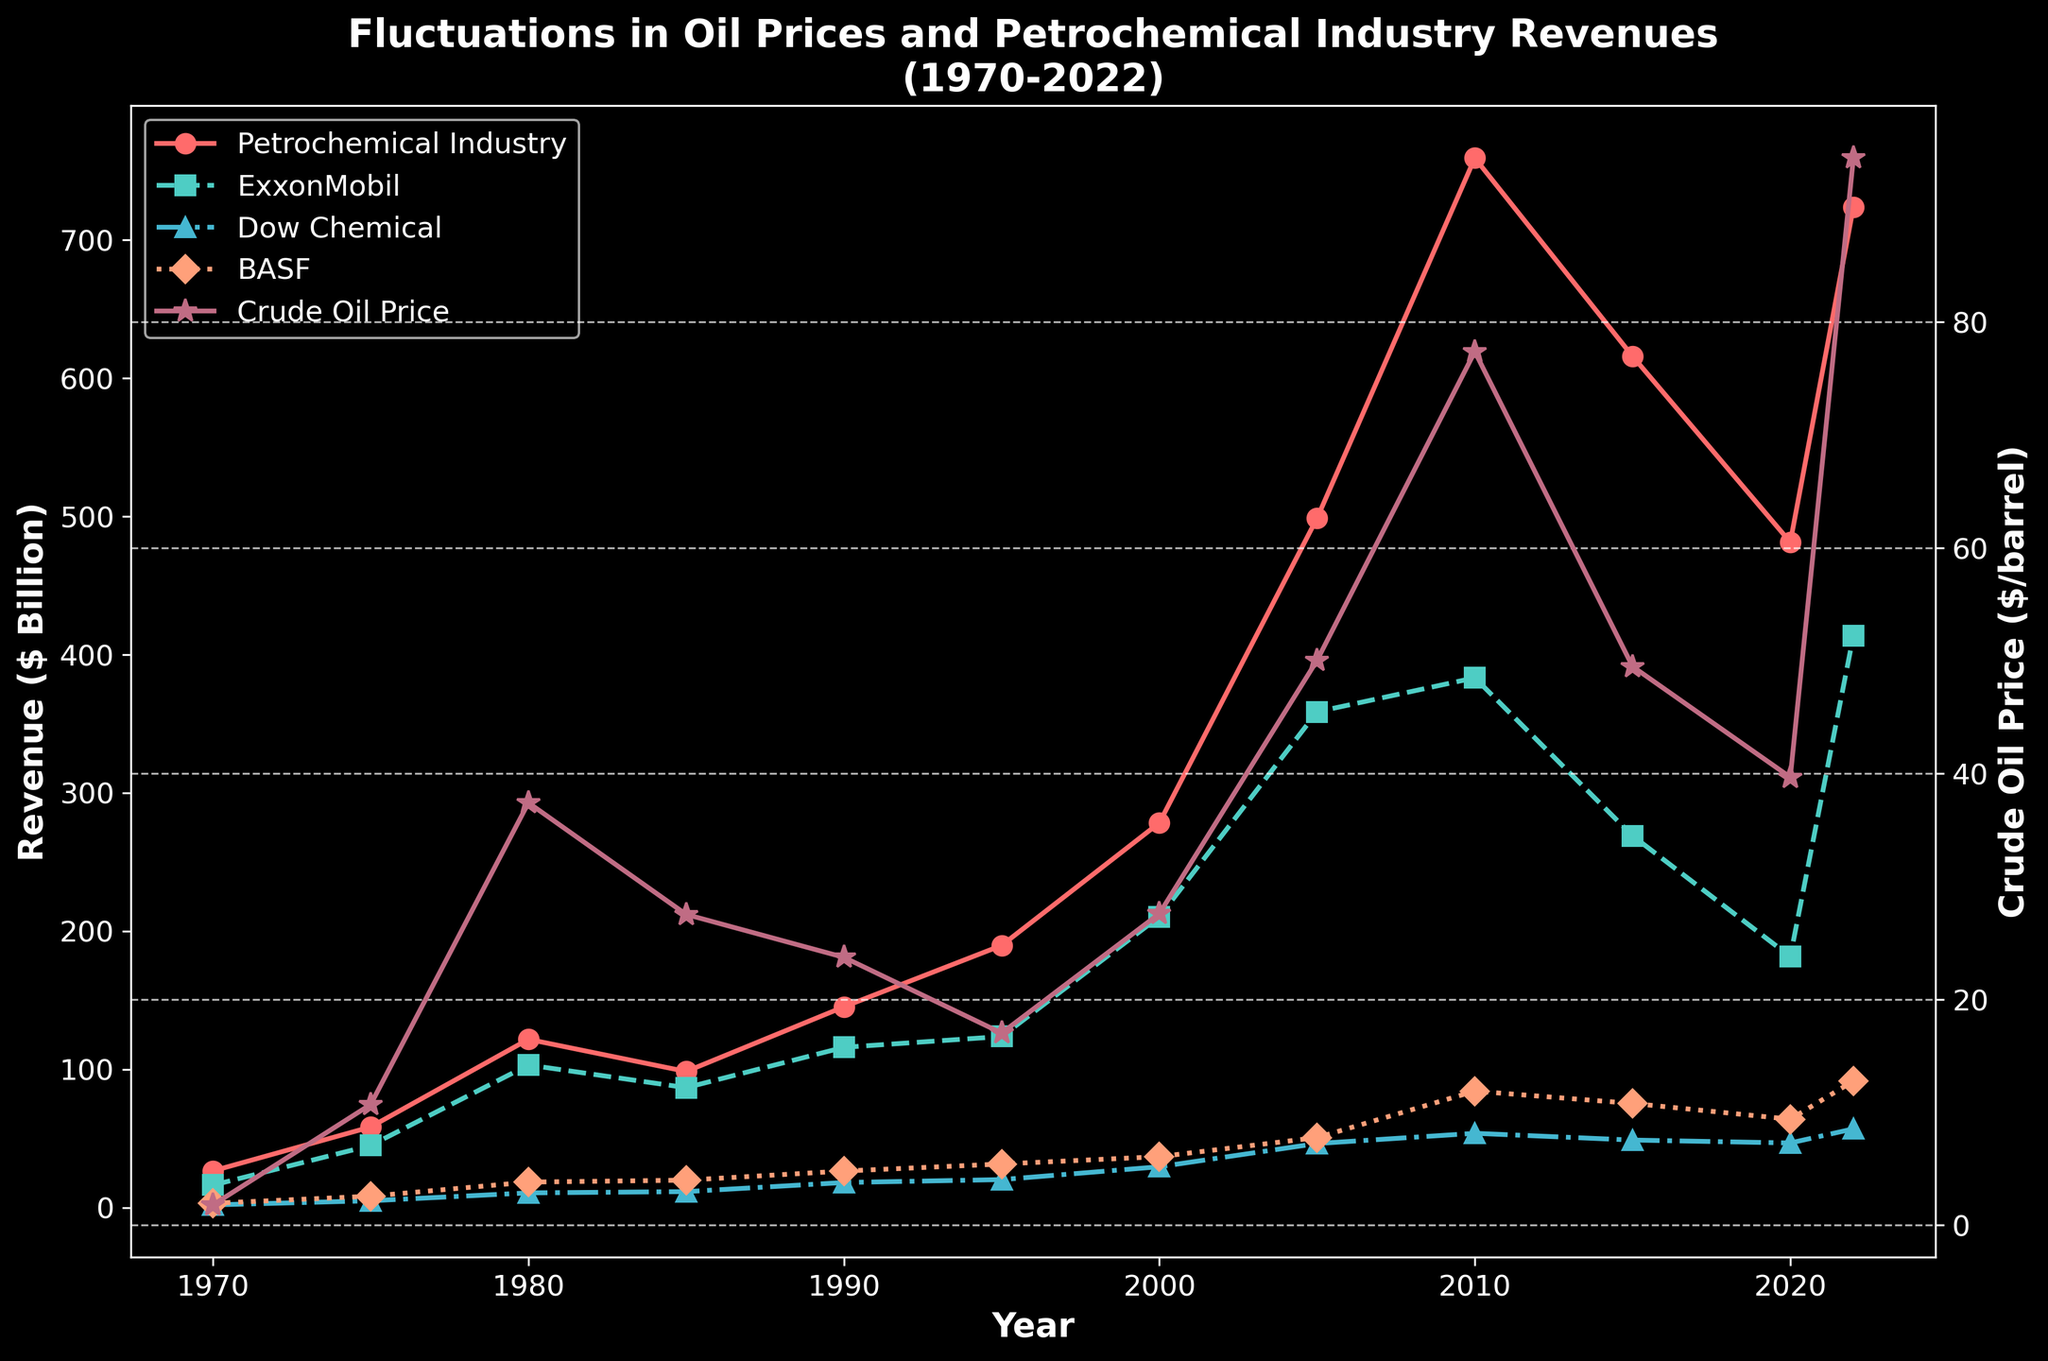What was the Petrochemical Industry Revenue in 1980? Find the point on the Petrochemical Industry Revenue line corresponding to the year 1980. The value at this point is 121.7.
Answer: 121.7 billion dollars Which company had the highest revenue in 2022? Compare the revenues of ExxonMobil, Dow Chemical, and BASF for the year 2022. ExxonMobil has 413.7, Dow Chemical has 56.9, and BASF has 91.5. ExxonMobil has the highest revenue.
Answer: ExxonMobil During which year was the Crude Oil Price the highest, and how much was it? Identify the highest point on the Crude Oil Price line, which occurs in 2022. The corresponding value is 94.53.
Answer: 2022 and 94.53 dollars per barrel Between which years did ExxonMobil’s Revenue experience the largest drop? Compare the changes in ExxonMobil’s Revenue between consecutive years. The largest drop occurs between 2010 (383.2) and 2015 (268.9), giving a decrease of 114.3 billion dollars.
Answer: 2010 and 2015 What is the average revenue of Dow Chemical between 2000 and 2020? Find the revenues of Dow Chemical in the years 2000, 2005, 2010, 2015, and 2020. Sum them up: 29.5 + 46.3 + 53.7 + 48.8 + 46.7 = 225. Find the average: 225 / 5 = 45.
Answer: 45 billion dollars Did BASF Revenue ever surpass the Petrochemical Industry Revenue? If yes, when? Compare the lines representing BASF Revenue and Petrochemical Industry Revenue. BASF's line is always below the Petrochemical Industry Revenue line, meaning BASF never surpassed the Petrochemical Industry Revenue.
Answer: No During which year did Crude Oil Price approximately double its value compared to the previous year? Search for a year-to-year increase where the Crude Oil Price approximately doubles. In 1975, the Crude Oil Price is 10.70, roughly 6 times the value in 1970 (1.80). While not an exact double, such a significant increase only occurs between these years.
Answer: 1975 Which year showed the highest revenue for the Petrochemical Industry, and what was the amount? Identify the highest point on the Petrochemical Industry Revenue line, which occurs in 2010. The value at this point is 759.2.
Answer: 2010 and 759.2 billion dollars How did Dow Chemical Revenue trend from 1995 to 2000 compared to Crude Oil Price? Compare the trend lines for Dow Chemical Revenue and Crude Oil Price from 1995 to 2000. Dow Chemical Revenue increased from 20.2 to 29.5 (an increasing trend), while Crude Oil Price also increased from 17.02 to 27.60 (an increasing trend).
Answer: Both increased By how much did BASF Revenue increase from 1970 to 2022? Find the BASF Revenues for 1970 (3.1) and 2022 (91.5). Subtract the 1970 value from the 2022 value to find the increase: 91.5 - 3.1 = 88.4.
Answer: 88.4 billion dollars 